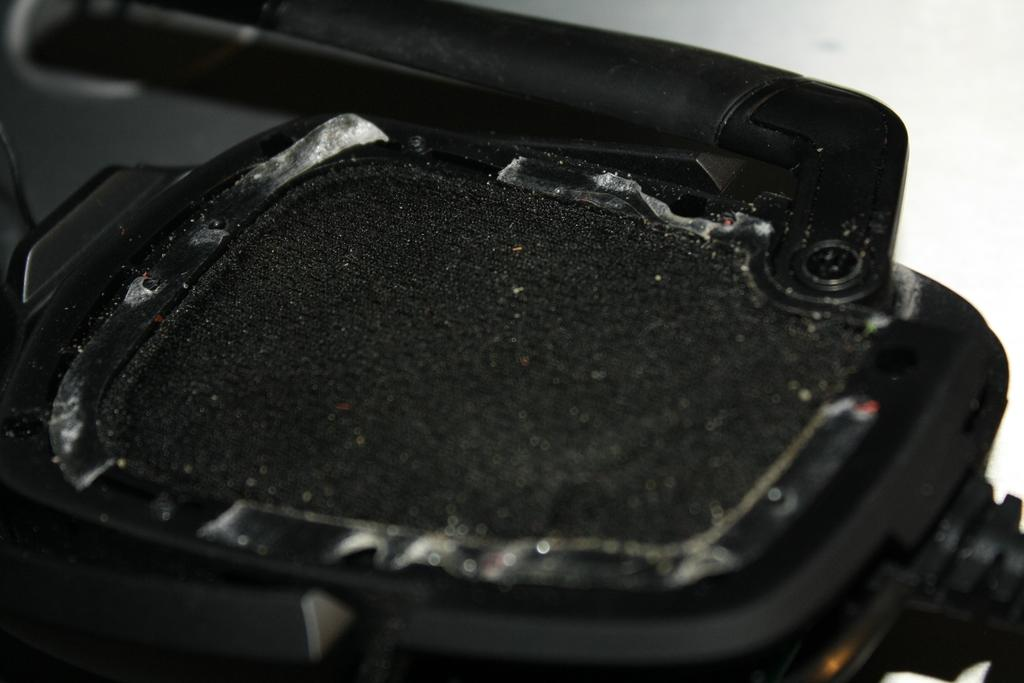What is the main subject in the center of the image? There is an object in the center of the image. What can be said about the color of the object? The object is black in color. How much lettuce is needed to make the toothpaste in the image? There is no toothpaste or lettuce present in the image. The image only features a black object in the center. 